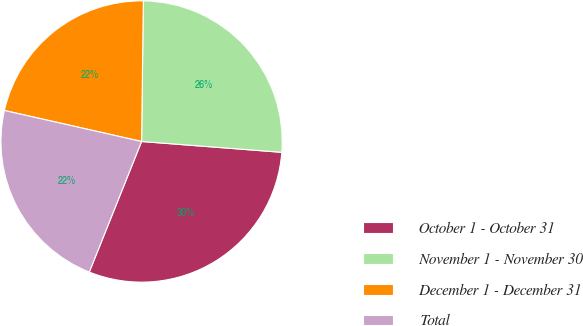Convert chart to OTSL. <chart><loc_0><loc_0><loc_500><loc_500><pie_chart><fcel>October 1 - October 31<fcel>November 1 - November 30<fcel>December 1 - December 31<fcel>Total<nl><fcel>29.84%<fcel>26.03%<fcel>21.66%<fcel>22.48%<nl></chart> 